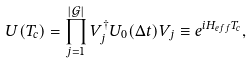<formula> <loc_0><loc_0><loc_500><loc_500>U ( T _ { c } ) = \prod _ { j = 1 } ^ { | \mathcal { G } | } V _ { j } ^ { \dagger } U _ { 0 } ( \Delta t ) V _ { j } \equiv e ^ { i H _ { e f f } T _ { c } } ,</formula> 